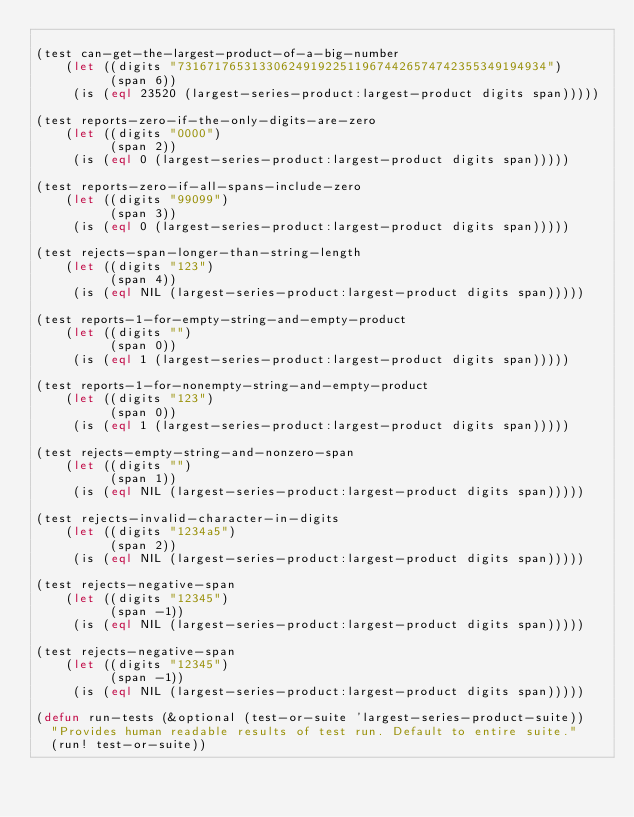<code> <loc_0><loc_0><loc_500><loc_500><_Lisp_>
(test can-get-the-largest-product-of-a-big-number
    (let ((digits "73167176531330624919225119674426574742355349194934")
          (span 6))
     (is (eql 23520 (largest-series-product:largest-product digits span)))))

(test reports-zero-if-the-only-digits-are-zero
    (let ((digits "0000")
          (span 2))
     (is (eql 0 (largest-series-product:largest-product digits span)))))

(test reports-zero-if-all-spans-include-zero
    (let ((digits "99099")
          (span 3))
     (is (eql 0 (largest-series-product:largest-product digits span)))))

(test rejects-span-longer-than-string-length
    (let ((digits "123")
          (span 4))
     (is (eql NIL (largest-series-product:largest-product digits span)))))

(test reports-1-for-empty-string-and-empty-product
    (let ((digits "")
          (span 0))
     (is (eql 1 (largest-series-product:largest-product digits span)))))

(test reports-1-for-nonempty-string-and-empty-product
    (let ((digits "123")
          (span 0))
     (is (eql 1 (largest-series-product:largest-product digits span)))))

(test rejects-empty-string-and-nonzero-span
    (let ((digits "")
          (span 1))
     (is (eql NIL (largest-series-product:largest-product digits span)))))

(test rejects-invalid-character-in-digits
    (let ((digits "1234a5")
          (span 2))
     (is (eql NIL (largest-series-product:largest-product digits span)))))

(test rejects-negative-span
    (let ((digits "12345")
          (span -1))
     (is (eql NIL (largest-series-product:largest-product digits span)))))

(test rejects-negative-span
    (let ((digits "12345")
          (span -1))
     (is (eql NIL (largest-series-product:largest-product digits span)))))

(defun run-tests (&optional (test-or-suite 'largest-series-product-suite))
  "Provides human readable results of test run. Default to entire suite."
  (run! test-or-suite))
</code> 